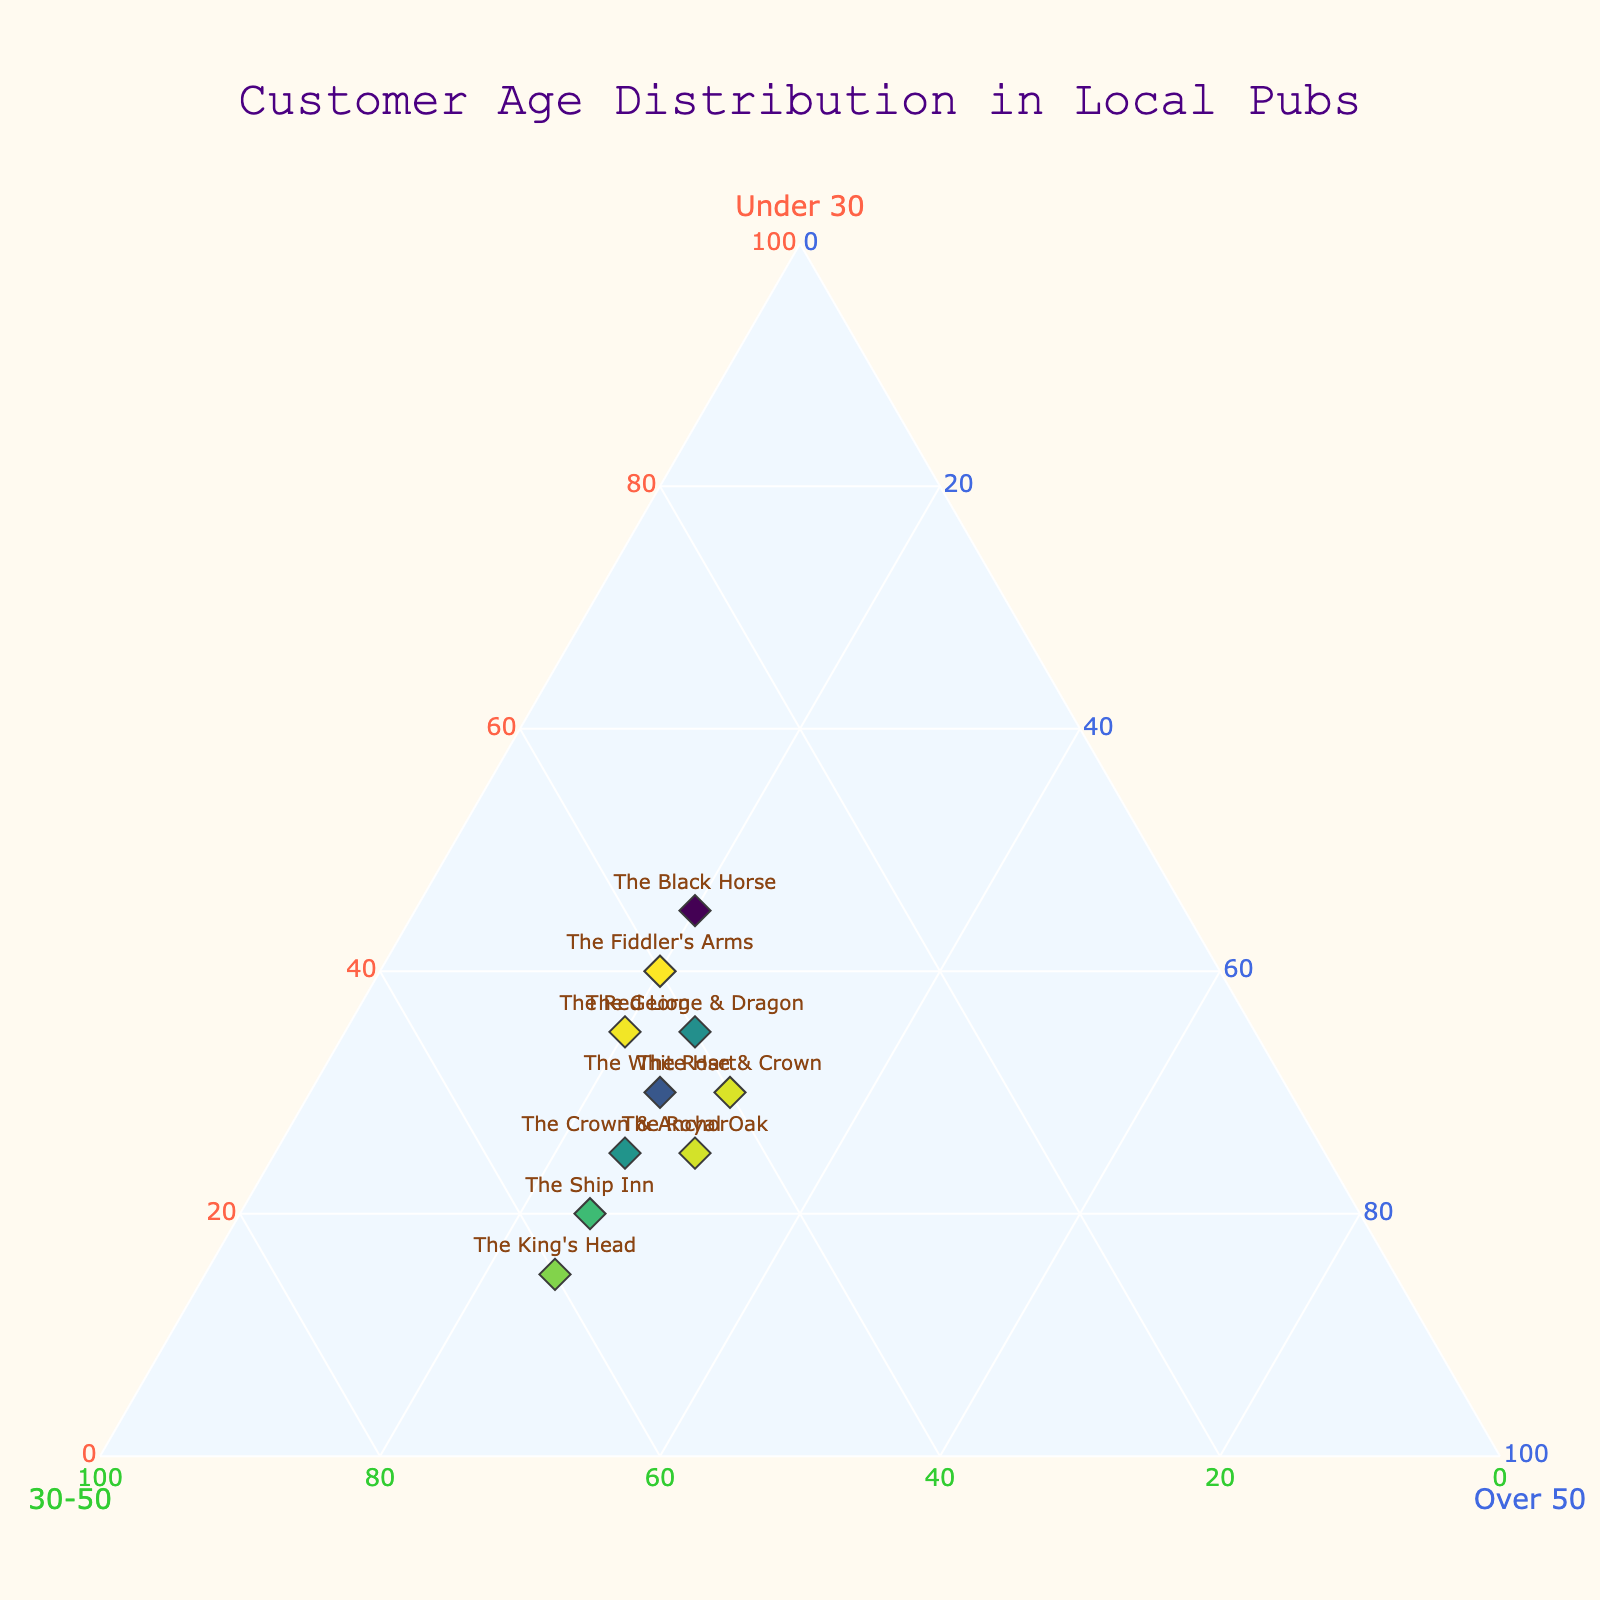Which pub has the highest percentage of customers under 30? The Fiddler's Arms and The Black Horse have the highest percentage of customers under 30 with 40%.
Answer: The Fiddler's Arms and The Black Horse How many pubs have equal percentages of customers in the '30-50' and 'Over 50' age groups? Look for data points where the values in the '30-50' and 'Over 50' categories are equal. The Crown & Anchor has 50 in the '30-50' and 'Over 50' categories.
Answer: One Which pub has the largest proportion of customers aged 30-50 compared to the other age groups? The King's Head has the highest percentage (60%) of customers aged 30-50.
Answer: The King's Head What is the total number of customers in the 'Under 30' and 'Over 50' groups for The Red Lion? Add the 'Under 30' and 'Over 50' values for The Red Lion: 35+20 = 55.
Answer: 55 Which pub has the smallest percentage of customers over 50? The Black Horse has the smallest percentage of customers over 50 with 20%.
Answer: The Black Horse What is the average percentage of customers aged 30-50 across all pubs? Sum the percentages in the '30-50' column and divide by the number of pubs: (45+50+40+55+40+60+35+45+45+40)/10 = 45%.
Answer: 45% Compare The George & Dragon to The Ship Inn; which has more customers aged under 30? The George & Dragon has 35 customers under 30, while The Ship Inn has 20. Therefore, The George & Dragon has more.
Answer: The George & Dragon Which pub has a perfectly balanced distribution among all three age groups? The Rose & Crown has 30% in each age group.
Answer: The Rose & Crown Identify the pub with the most significant difference between the 'Under 30' and 'Over 50' age groups. Calculate the absolute difference for each pub and find the maximum difference. The Black Horse has a difference of 25 (45% under 30, 20% over 50).
Answer: The Black Horse 